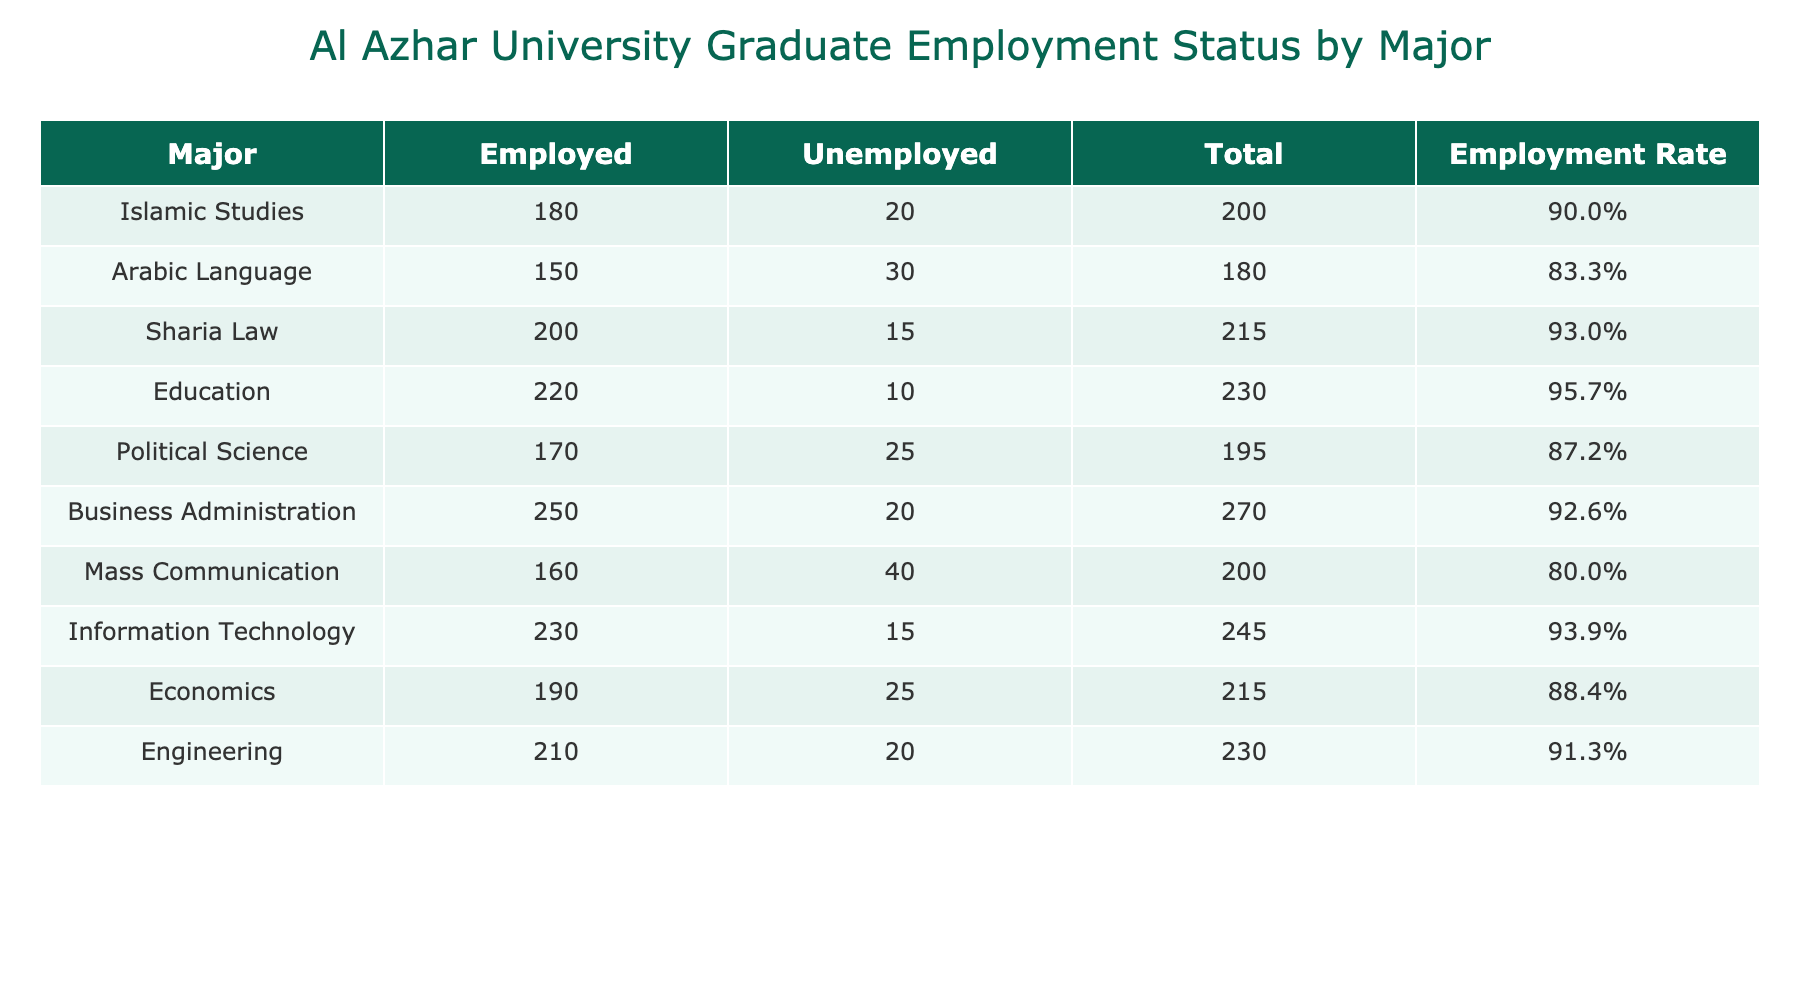What is the total number of Business Administration graduates? The number of graduates from the Business Administration major who are employed is 250, and those who are unemployed is 20. To find the total number, we sum these values: 250 + 20 = 270.
Answer: 270 Which major has the highest employment rate? To find the major with the highest employment rate, we compare the employment rates provided in the table. The major with the highest employment rate is Information Technology at 93.5%.
Answer: Information Technology What is the difference in the number of employed graduates between Engineering and Political Science? For Engineering, the number of employed graduates is 210, and for Political Science, it is 170. The difference is calculated as 210 - 170 = 40.
Answer: 40 Are there more unemployed graduates in Mass Communication than in Arabic Language? The number of unemployed graduates in Mass Communication is 40, while in Arabic Language it is 30. Since 40 is greater than 30, the statement is true.
Answer: Yes What is the average number of employed graduates across all majors? To calculate the average number of employed graduates, sum all the employed counts: 180 + 150 + 200 + 220 + 170 + 250 + 160 + 230 + 190 + 210 = 1950. There are 10 majors, so the average is 1950 / 10 = 195.
Answer: 195 Which major has the least number of unemployed graduates? By checking the 'Unemployed' column, we find that the major with the least number of unemployed graduates is Education with 10.
Answer: Education What is the total unemployed population among all majors? To find the total number of unemployed graduates, we need to sum the unemployed counts: 20 + 30 + 15 + 10 + 25 + 20 + 40 + 15 + 25 + 20 =  225.
Answer: 225 Is the employment rate for Sharia Law greater than 90%? The employment rate for Sharia Law is calculated as (200 employed / 215 total) * 100 = 93.0%. Since 93.0% is indeed greater than 90%, the statement is true.
Answer: Yes 